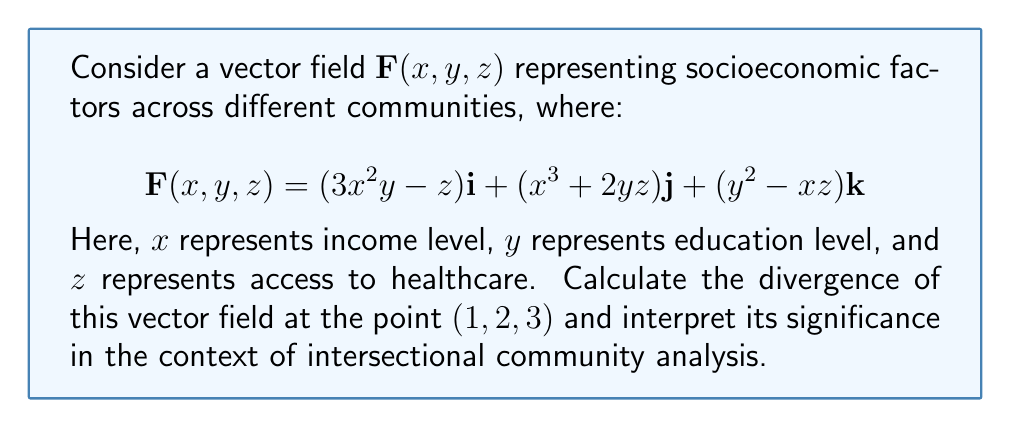Teach me how to tackle this problem. To solve this problem, we'll follow these steps:

1) The divergence of a vector field $\mathbf{F}(x, y, z) = P\mathbf{i} + Q\mathbf{j} + R\mathbf{k}$ is given by:

   $$\text{div}\mathbf{F} = \nabla \cdot \mathbf{F} = \frac{\partial P}{\partial x} + \frac{\partial Q}{\partial y} + \frac{\partial R}{\partial z}$$

2) In our case:
   $P = 3x^2y - z$
   $Q = x^3 + 2yz$
   $R = y^2 - xz$

3) Let's calculate each partial derivative:

   $\frac{\partial P}{\partial x} = 6xy$
   $\frac{\partial Q}{\partial y} = 2z$
   $\frac{\partial R}{\partial z} = -x$

4) Now, we can sum these partial derivatives:

   $$\text{div}\mathbf{F} = 6xy + 2z - x$$

5) Evaluating at the point $(1, 2, 3)$:

   $$\text{div}\mathbf{F}(1, 2, 3) = 6(1)(2) + 2(3) - 1 = 12 + 6 - 1 = 17$$

6) Interpretation: The positive divergence (17) at (1, 2, 3) indicates a net outflow of socioeconomic factors at this point. In the context of intersectional community analysis, this suggests that communities with moderate income (x=1), above-average education (y=2), and good healthcare access (z=3) are experiencing a concentration of socioeconomic advantages. This could indicate growing inequality, as resources and opportunities are flowing into these communities, potentially at the expense of less privileged areas.
Answer: 17; indicating resource concentration in moderately privileged communities 